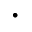Convert formula to latex. <formula><loc_0><loc_0><loc_500><loc_500>\cdot</formula> 